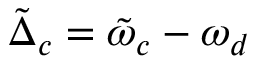Convert formula to latex. <formula><loc_0><loc_0><loc_500><loc_500>\tilde { \Delta } _ { c } = \tilde { \omega } _ { c } - \omega _ { d }</formula> 